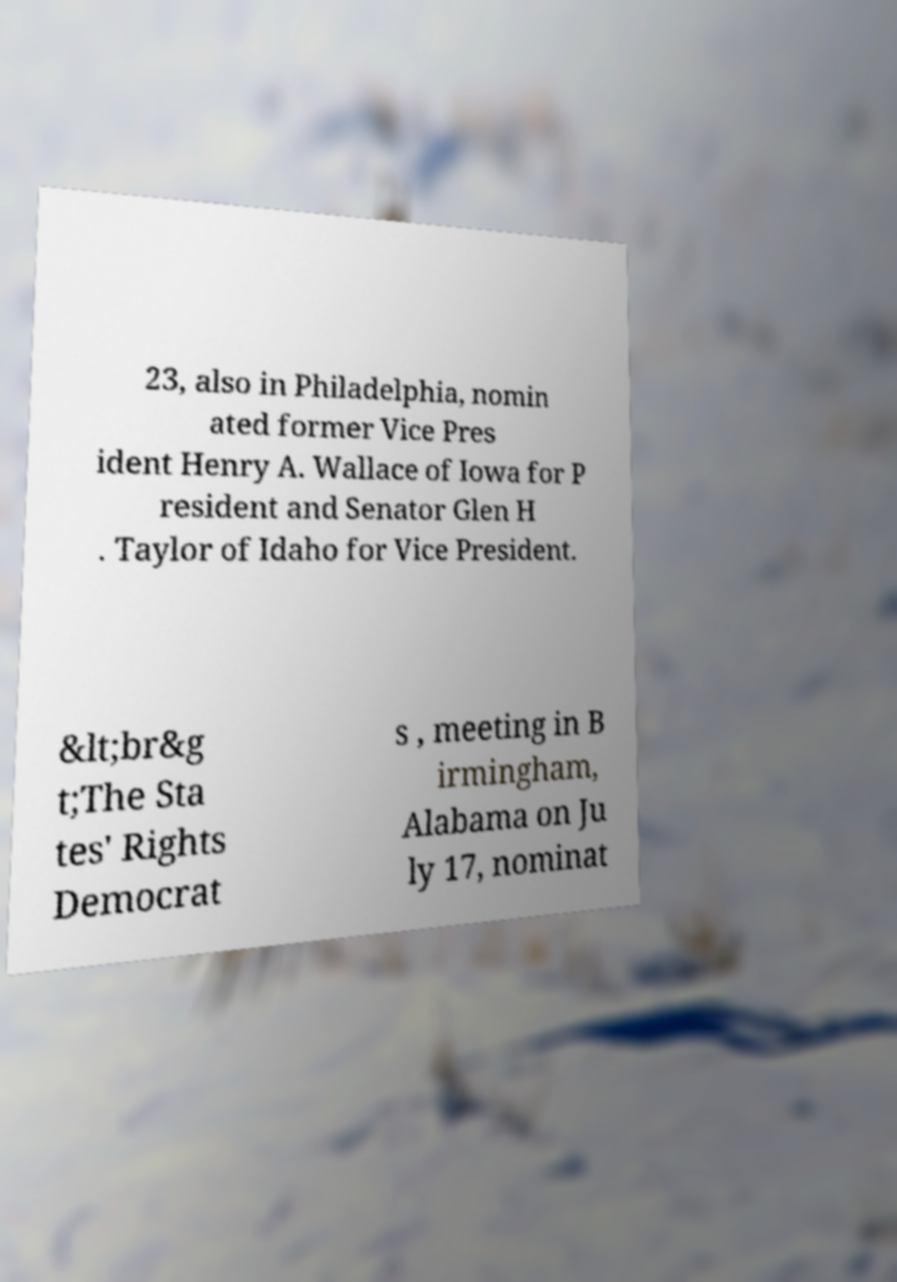There's text embedded in this image that I need extracted. Can you transcribe it verbatim? 23, also in Philadelphia, nomin ated former Vice Pres ident Henry A. Wallace of Iowa for P resident and Senator Glen H . Taylor of Idaho for Vice President. &lt;br&g t;The Sta tes' Rights Democrat s , meeting in B irmingham, Alabama on Ju ly 17, nominat 